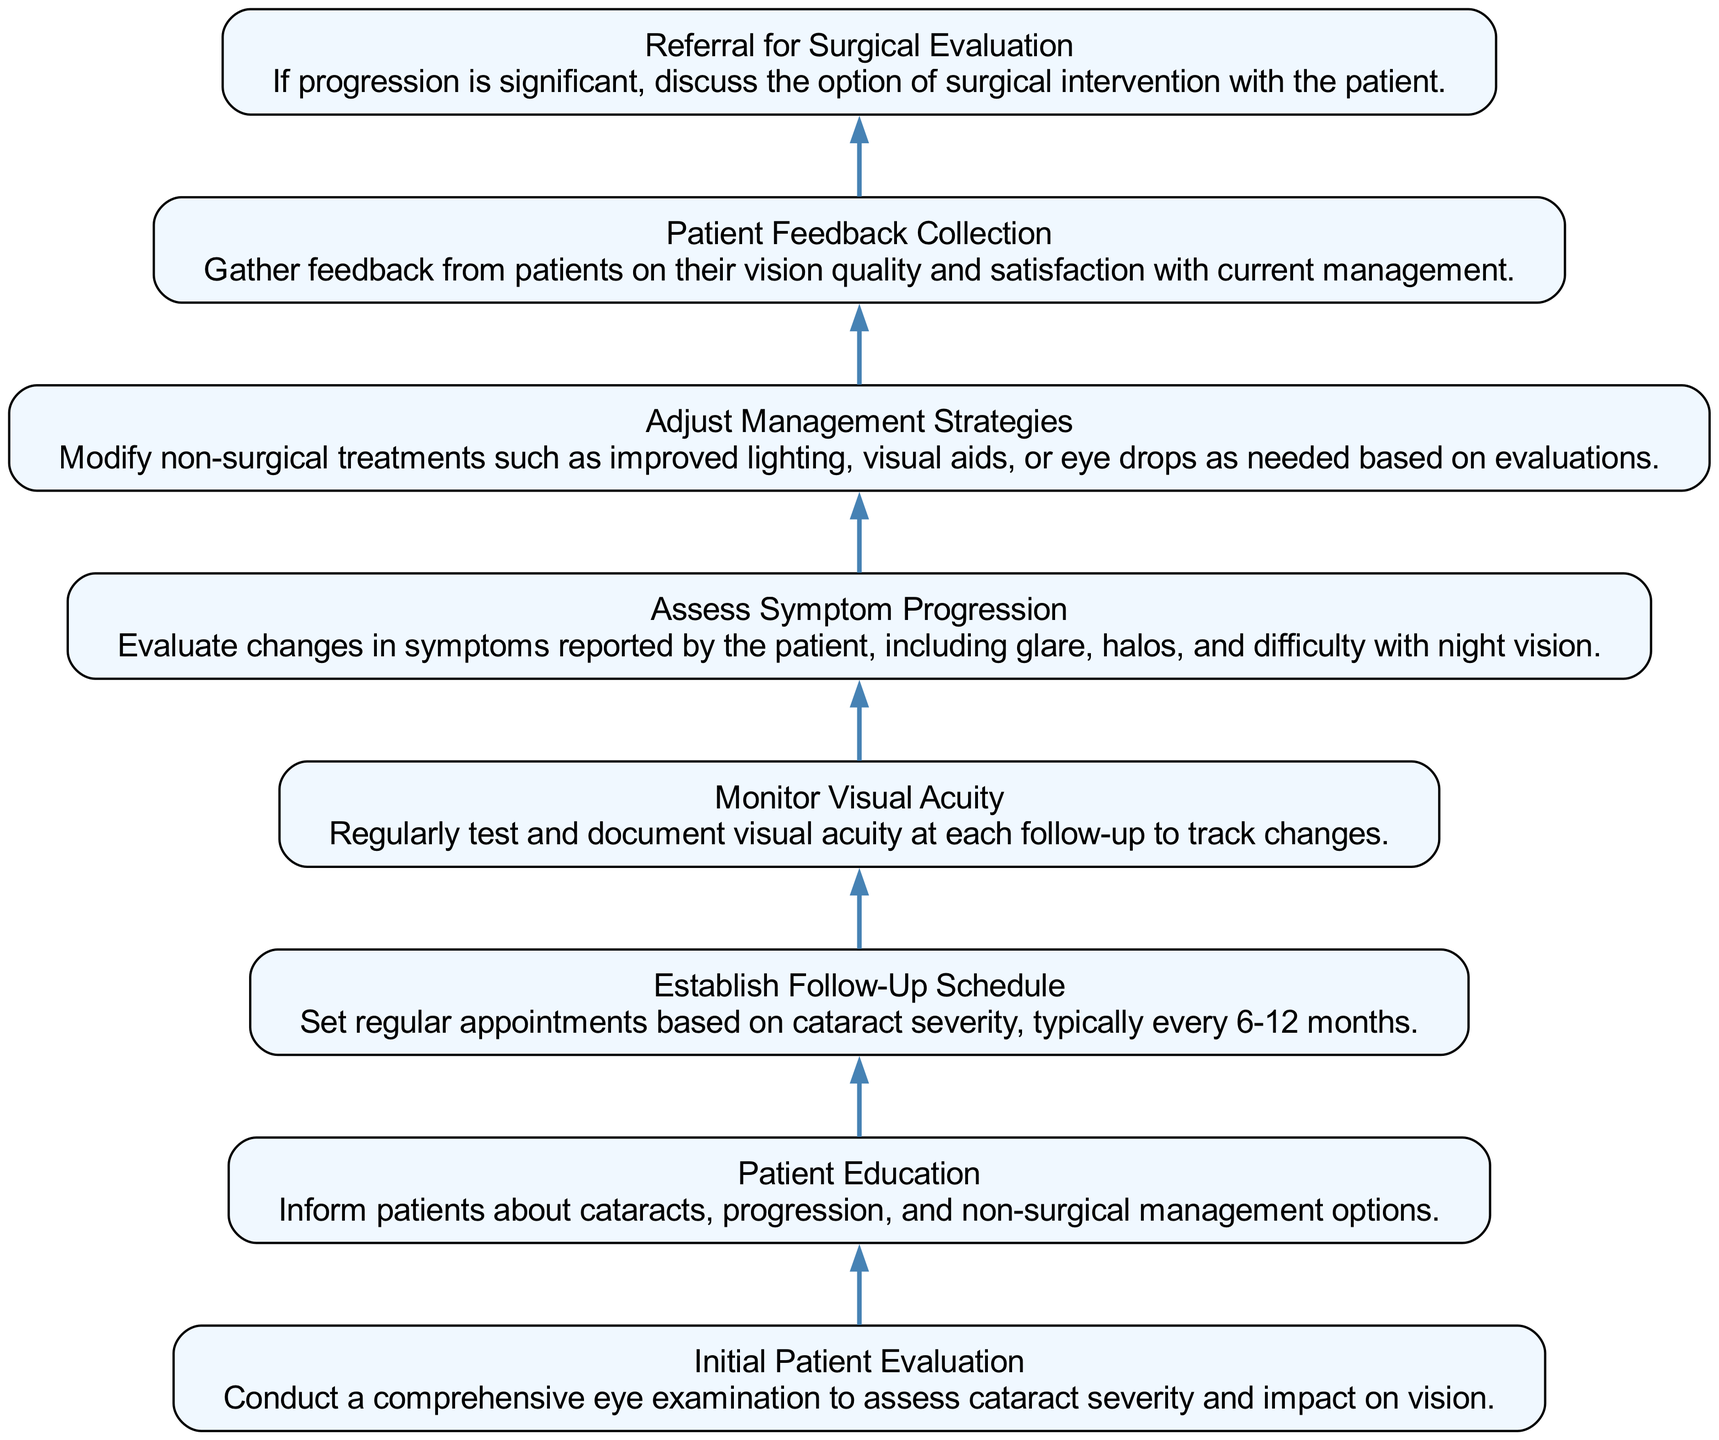What is the first step in the flow chart? The first step is "Initial Patient Evaluation," as it appears at the top of the flow chart. This is where the comprehensive eye examination takes place to assess cataract severity.
Answer: Initial Patient Evaluation How many nodes are there in the diagram? By counting the individual steps represented, there are eight nodes in total which correspond to the different stages of the patient management process.
Answer: 8 What follows directly after "Patient Education"? The next step after "Patient Education" is "Establish Follow-Up Schedule." This indicates a sequential flow from educating the patient to scheduling follow-up visits.
Answer: Establish Follow-Up Schedule What is assessed during the "Monitor Visual Acuity" step? This step involves regularly testing and documenting visual acuity, which helps in tracking any changes in the patient's vision over time.
Answer: Visual acuity Which steps involve patient input or feedback? The steps involving patient input are "Patient Education" and "Patient Feedback Collection," where patients are informed about their condition and their feedback is actively gathered on management satisfaction.
Answer: Patient Education, Patient Feedback Collection What is the final option discussed if significant progression is noted? If the progression of cataracts is significant, the last step in the flow chart is to discuss the option of "Referral for Surgical Evaluation" with the patient, indicating a possible transition to surgery.
Answer: Referral for Surgical Evaluation Which steps are directly linked without any other intermediary step? "Establish Follow-Up Schedule" is directly linked to "Monitor Visual Acuity," and "Adjust Management Strategies" connects to "Patient Feedback Collection," indicating a close relationship between these nodes.
Answer: Establish Follow-Up Schedule, Monitor Visual Acuity; Adjust Management Strategies, Patient Feedback Collection What aspect is checked in the "Assess Symptom Progression"? This aspect evaluates changes in symptoms reported by the patient, which includes issues such as glare, halos, and difficulty with night vision, crucial for understanding the impact of cataracts.
Answer: Changes in symptoms 